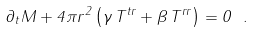<formula> <loc_0><loc_0><loc_500><loc_500>\partial _ { t } M + 4 \pi r ^ { 2 } \left ( \gamma \, T ^ { t r } + \beta \, T ^ { r r } \right ) = 0 \ .</formula> 